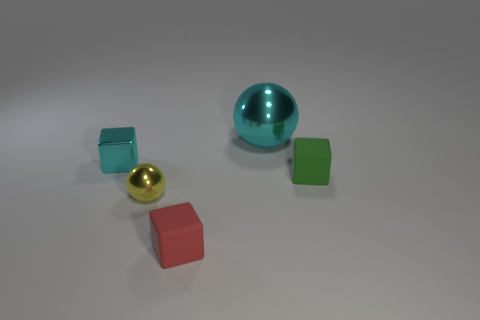What is the cyan thing that is left of the rubber object to the left of the big metal object made of?
Offer a very short reply. Metal. What material is the cyan object that is the same shape as the small green object?
Offer a very short reply. Metal. Are any big gray shiny blocks visible?
Offer a terse response. No. There is a small red object that is the same material as the small green cube; what shape is it?
Give a very brief answer. Cube. What material is the big cyan thing that is behind the small yellow sphere?
Give a very brief answer. Metal. There is a metal object right of the small red cube; is it the same color as the tiny shiny cube?
Your answer should be very brief. Yes. There is a red rubber thing that is on the left side of the tiny rubber cube behind the yellow ball; how big is it?
Provide a succinct answer. Small. Is the number of things that are in front of the big ball greater than the number of tiny red objects?
Provide a short and direct response. Yes. Does the cyan thing left of the yellow object have the same size as the yellow thing?
Offer a terse response. Yes. What is the color of the small block that is behind the small red cube and in front of the tiny shiny cube?
Your answer should be compact. Green. 